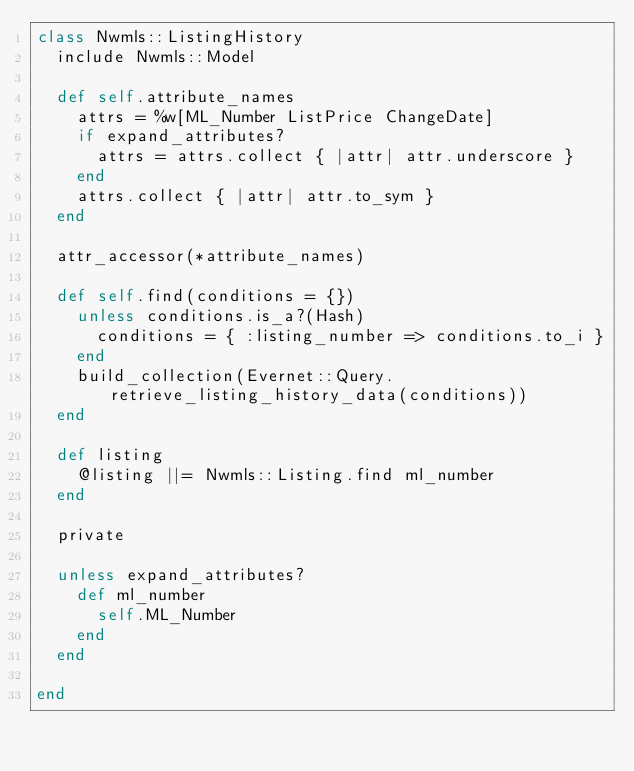<code> <loc_0><loc_0><loc_500><loc_500><_Ruby_>class Nwmls::ListingHistory
  include Nwmls::Model

  def self.attribute_names
    attrs = %w[ML_Number ListPrice ChangeDate]
    if expand_attributes?
      attrs = attrs.collect { |attr| attr.underscore }
    end
    attrs.collect { |attr| attr.to_sym }
  end

  attr_accessor(*attribute_names)

  def self.find(conditions = {})
    unless conditions.is_a?(Hash)
      conditions = { :listing_number => conditions.to_i }
    end
    build_collection(Evernet::Query.retrieve_listing_history_data(conditions))
  end

  def listing
    @listing ||= Nwmls::Listing.find ml_number
  end

  private

  unless expand_attributes?
    def ml_number
      self.ML_Number
    end
  end

end
</code> 